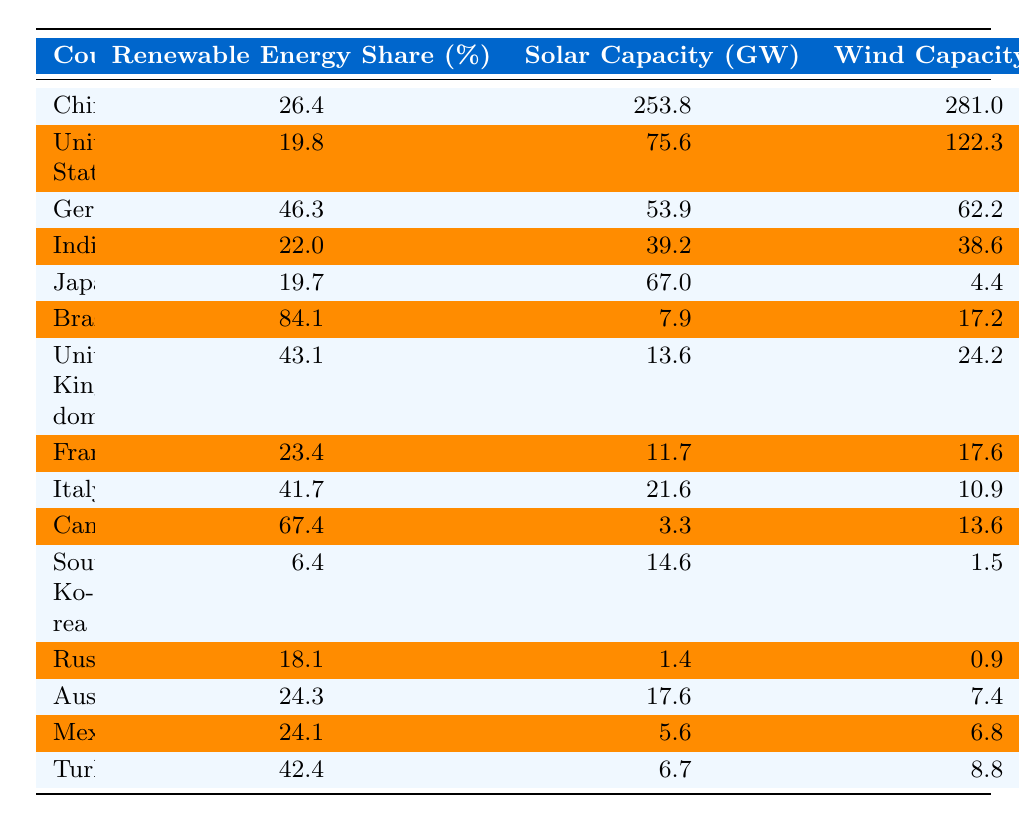What is the renewable energy share of Brazil? According to the table, Brazil has a renewable energy share of 84.1%.
Answer: 84.1% Which country has the highest solar capacity? From the table, China has the highest solar capacity at 253.8 GW.
Answer: 253.8 GW What is the wind capacity of Germany? The table shows that Germany has a wind capacity of 62.2 GW.
Answer: 62.2 GW Is the renewable energy share of the United States above 20%? The table indicates that the renewable energy share of the United States is 19.8%, which is not above 20%.
Answer: No What is the average renewable energy share of the top three countries? The top three countries based on renewable energy share are Brazil (84.1%), Germany (46.3%), and Canada (67.4%). The average is (84.1 + 46.3 + 67.4) / 3 = 65.26%.
Answer: 65.26% Which country has the least renewable energy share? The table shows that South Korea has the least renewable energy share at 6.4%.
Answer: 6.4% Considering both solar and wind capacities, which country has the most significant total capacity? For the total capacity, we add solar and wind capacities of each country. China has 253.8 GW (solar) + 281.0 GW (wind) = 534.8 GW, making it the highest.
Answer: China What is the difference in hydropower capacity between Canada and Russia? Canada has a hydropower capacity of 81.4 GW, while Russia has 49.9 GW. The difference is 81.4 GW - 49.9 GW = 31.5 GW.
Answer: 31.5 GW Which country has a renewable energy share closest to the average of all listed countries? To find the average, sum all the renewable energy shares (26.4 + 19.8 + 46.3 + 22 + 19.7 + 84.1 + 43.1 + 23.4 + 41.7 + 67.4 + 6.4 + 18.1 + 24.3 + 24.1 + 42.4) = 470.2. There are 15 countries, so the average is 470.2 / 15 = 31.35%. The country closest to this average is Australia at 24.3%.
Answer: Australia Does Germany have more wind capacity than the United States? Germany has a wind capacity of 62.2 GW, while the United States has 122.3 GW. Therefore, Germany does not have more wind capacity.
Answer: No 